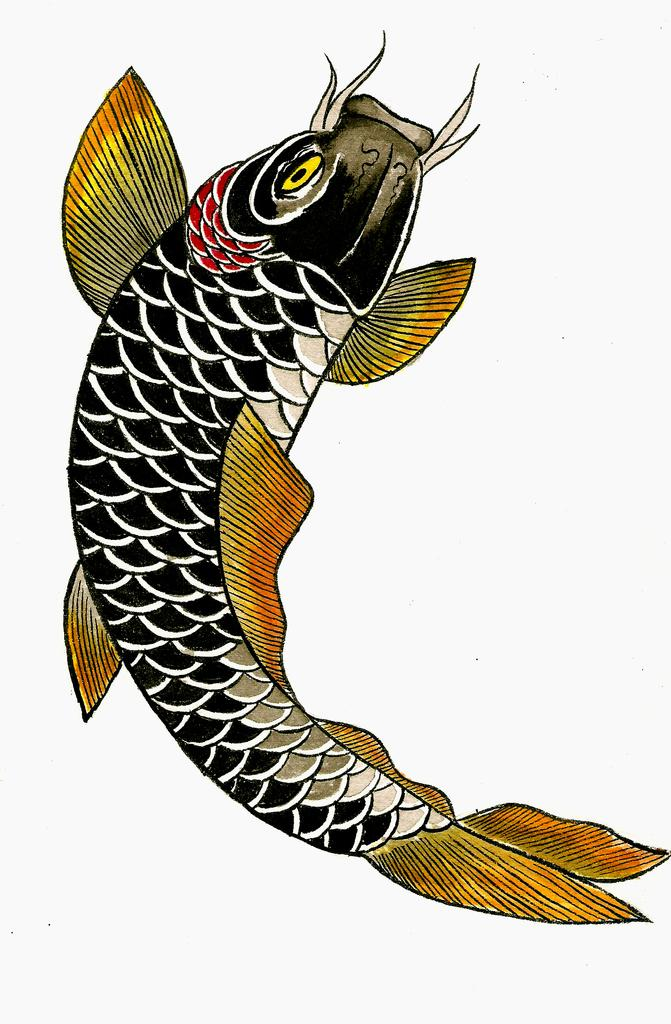What is the color of the fish in the image? The fish in the image is black. What other feature can be observed about the fish? The fish has colorful fins. Can you see any oranges near the seashore in the image? There is no seashore or oranges present in the image; it features a black fish with colorful fins. 